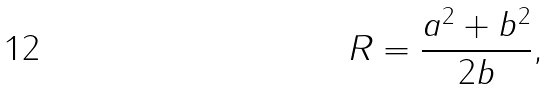Convert formula to latex. <formula><loc_0><loc_0><loc_500><loc_500>R = \frac { a ^ { 2 } + b ^ { 2 } } { 2 b } ,</formula> 